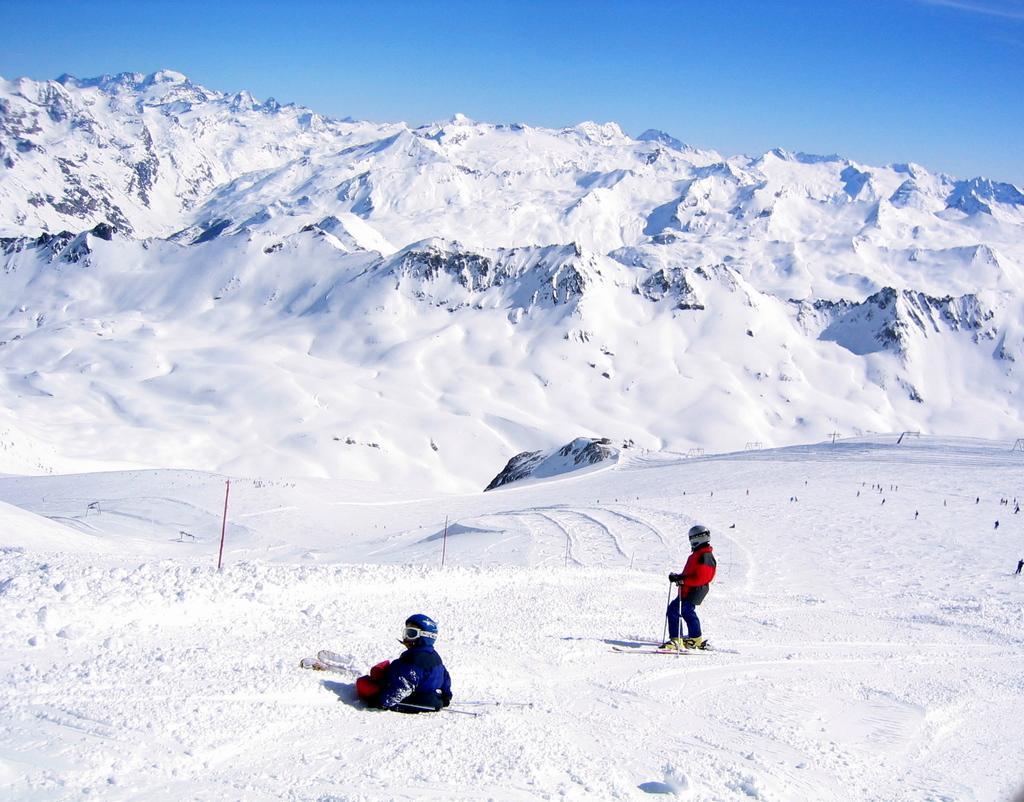Describe this image in one or two sentences. In this image I can see two persons are skiing on the mountain. In the background I can see a group of people and mountains. At the top I can see the blue sky. This image is taken may be during a sunny day. 